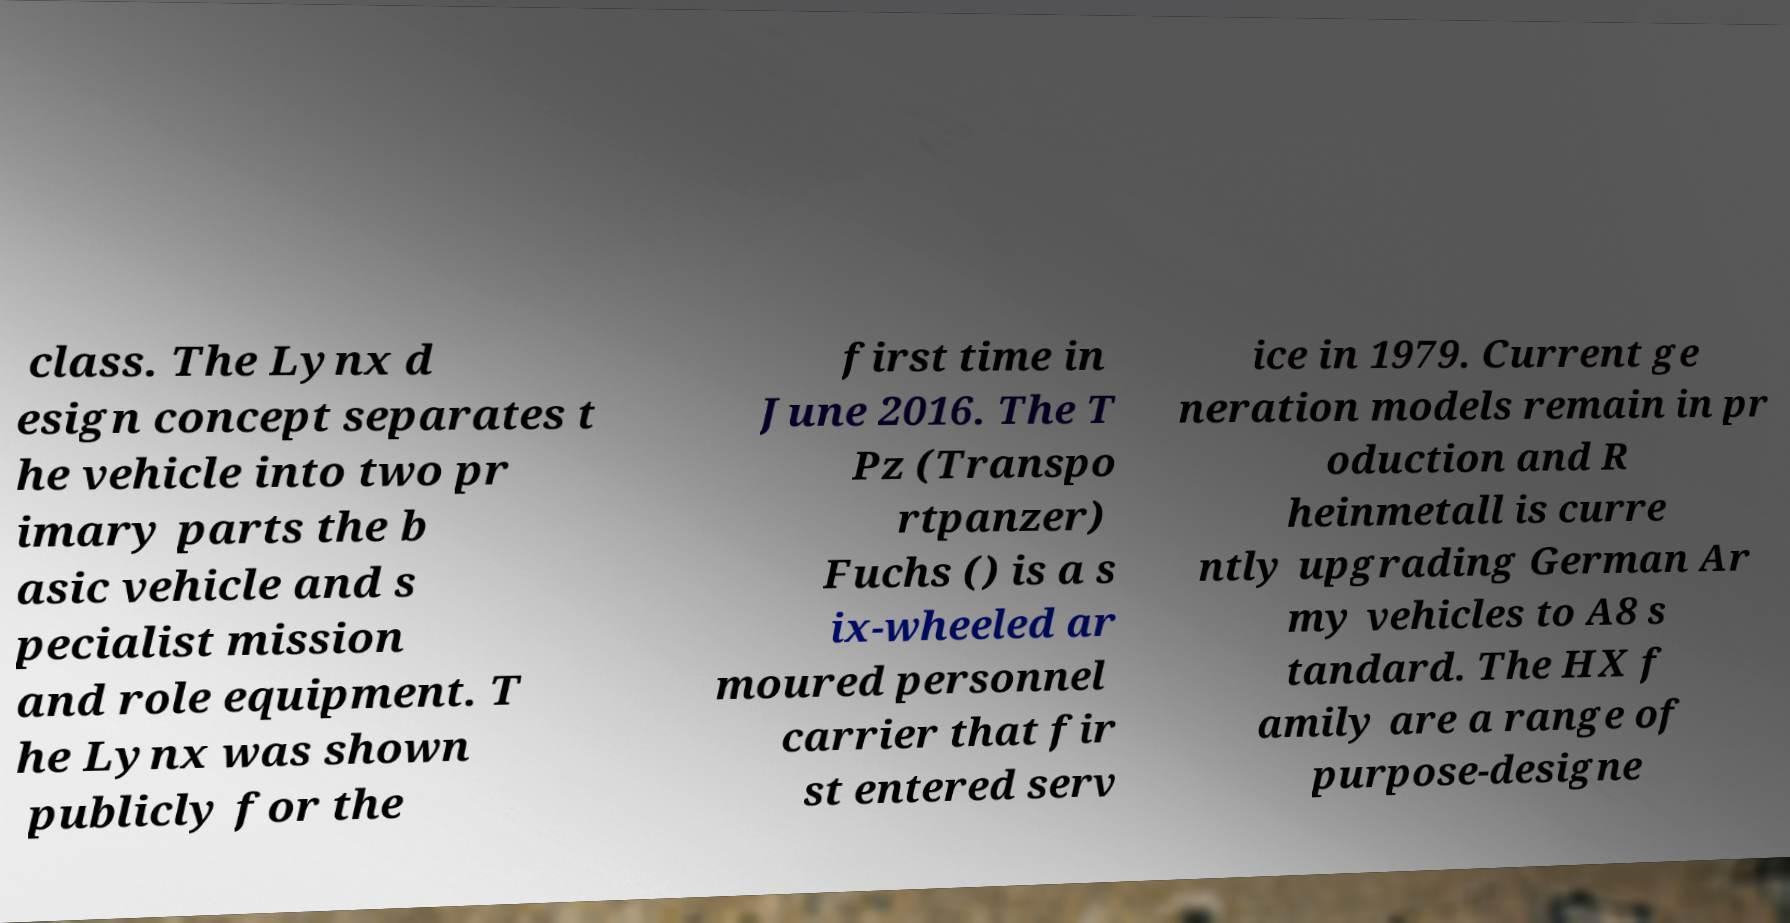Can you accurately transcribe the text from the provided image for me? class. The Lynx d esign concept separates t he vehicle into two pr imary parts the b asic vehicle and s pecialist mission and role equipment. T he Lynx was shown publicly for the first time in June 2016. The T Pz (Transpo rtpanzer) Fuchs () is a s ix-wheeled ar moured personnel carrier that fir st entered serv ice in 1979. Current ge neration models remain in pr oduction and R heinmetall is curre ntly upgrading German Ar my vehicles to A8 s tandard. The HX f amily are a range of purpose-designe 